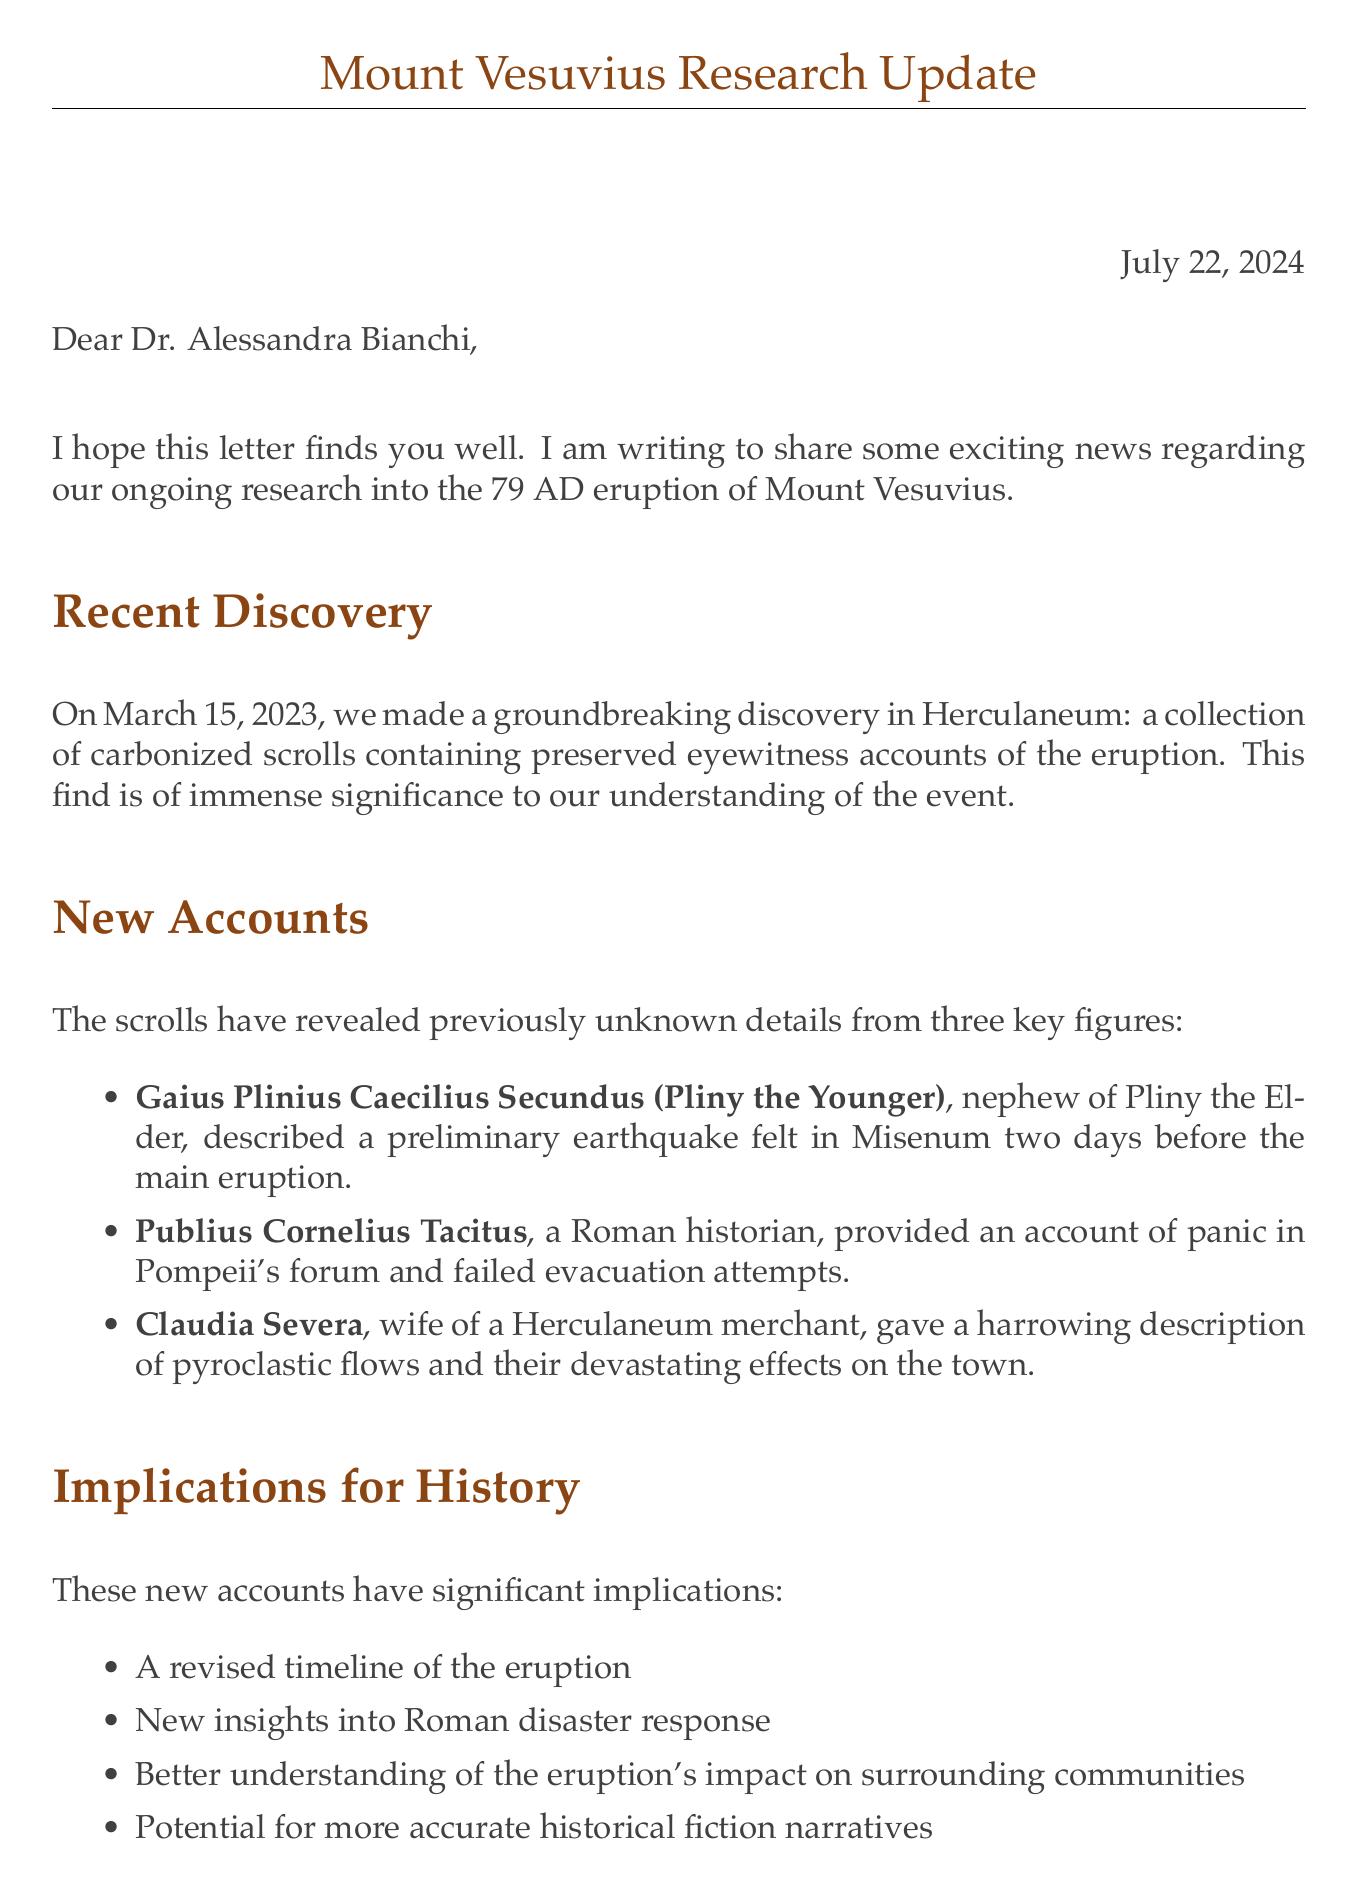What is the date of the recent discovery? The recent discovery of carbonized scrolls was made on March 15, 2023.
Answer: March 15, 2023 Who authored an account detailing panic in Pompeii's forum? Publius Cornelius Tacitus is the author who provided an account of panic in Pompeii's forum.
Answer: Publius Cornelius Tacitus What significant artifact was discovered in Herculaneum? The significant artifact discovered was a collection of carbonized scrolls.
Answer: Carbonized scrolls What new insight is offered regarding Roman disaster response? The document proposes new insights into Roman disaster response based on the newly discovered accounts.
Answer: New insights into Roman disaster response What future plan involves collaboration with scientists? The future plan includes collaboration with volcanologists to analyze described phenomena.
Answer: Collaborate with volcanologists Who is mentioned as the Roman Emperor at the time of the eruption? The letter mentions Titus as the Roman Emperor during the eruption.
Answer: Titus What does the letter suggest regarding the impact on historical fiction narratives? The letter suggests the potential for more accurate historical fiction narratives based on new accounts.
Answer: More accurate historical fiction narratives Which upcoming event is the author looking forward to? The author looks forward to discussing the findings at the upcoming International Conference on Roman Archaeology in Naples.
Answer: International Conference on Roman Archaeology in Naples 